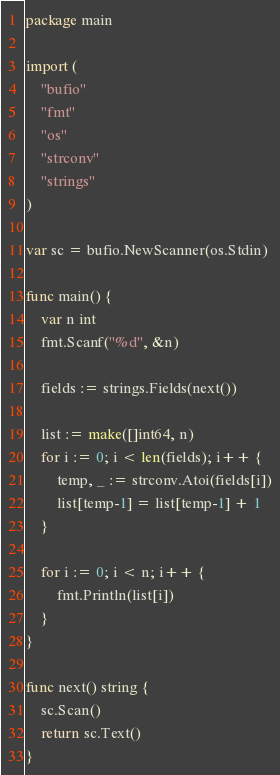Convert code to text. <code><loc_0><loc_0><loc_500><loc_500><_Go_>package main

import (
	"bufio"
	"fmt"
	"os"
	"strconv"
	"strings"
)

var sc = bufio.NewScanner(os.Stdin)

func main() {
	var n int
	fmt.Scanf("%d", &n)

	fields := strings.Fields(next())

	list := make([]int64, n)
	for i := 0; i < len(fields); i++ {
		temp, _ := strconv.Atoi(fields[i])
		list[temp-1] = list[temp-1] + 1
	}

	for i := 0; i < n; i++ {
		fmt.Println(list[i])
	}
}

func next() string {
	sc.Scan()
	return sc.Text()
}
</code> 